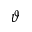<formula> <loc_0><loc_0><loc_500><loc_500>\vartheta</formula> 